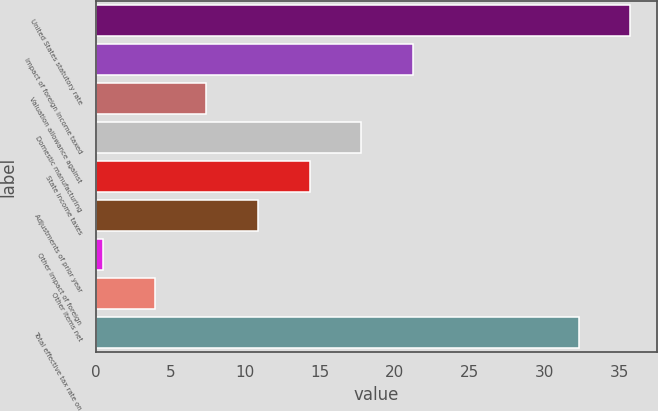Convert chart to OTSL. <chart><loc_0><loc_0><loc_500><loc_500><bar_chart><fcel>United States statutory rate<fcel>Impact of foreign income taxed<fcel>Valuation allowance against<fcel>Domestic manufacturing<fcel>State income taxes<fcel>Adjustments of prior year<fcel>Other impact of foreign<fcel>Other items net<fcel>Total effective tax rate on<nl><fcel>35.75<fcel>21.2<fcel>7.4<fcel>17.75<fcel>14.3<fcel>10.85<fcel>0.5<fcel>3.95<fcel>32.3<nl></chart> 